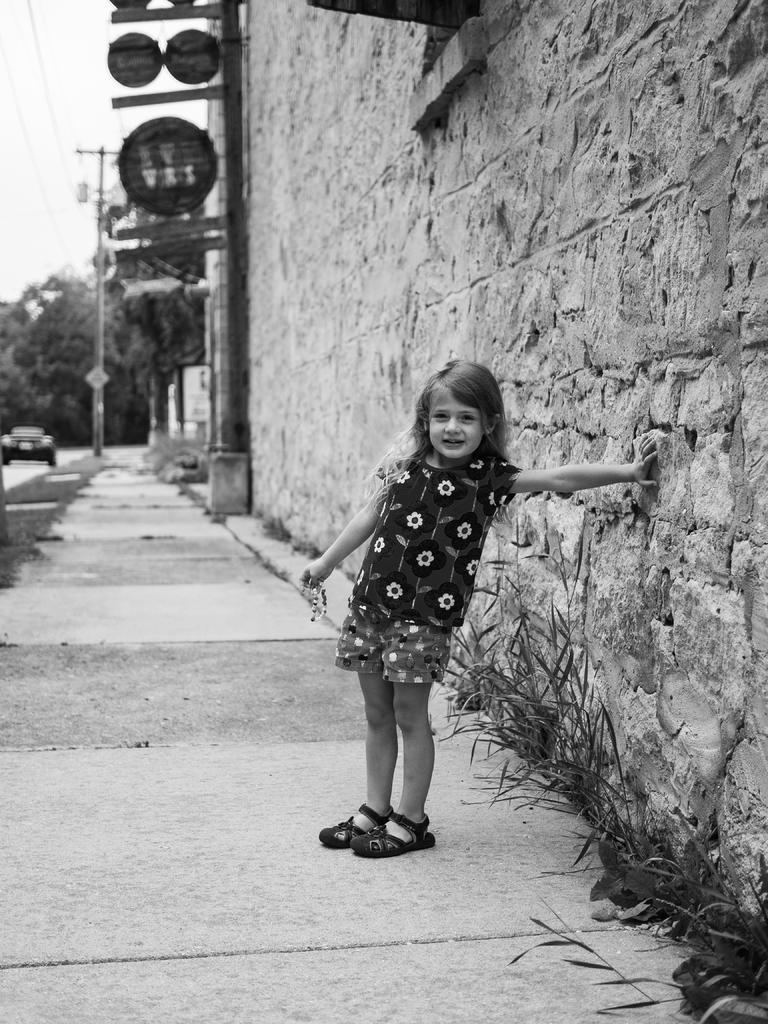Describe this image in one or two sentences. In this image we can see a child standing and touching the wall. And we can see there are boards attached to the pole. We can see a vehicle on the ground and sky in the background. 